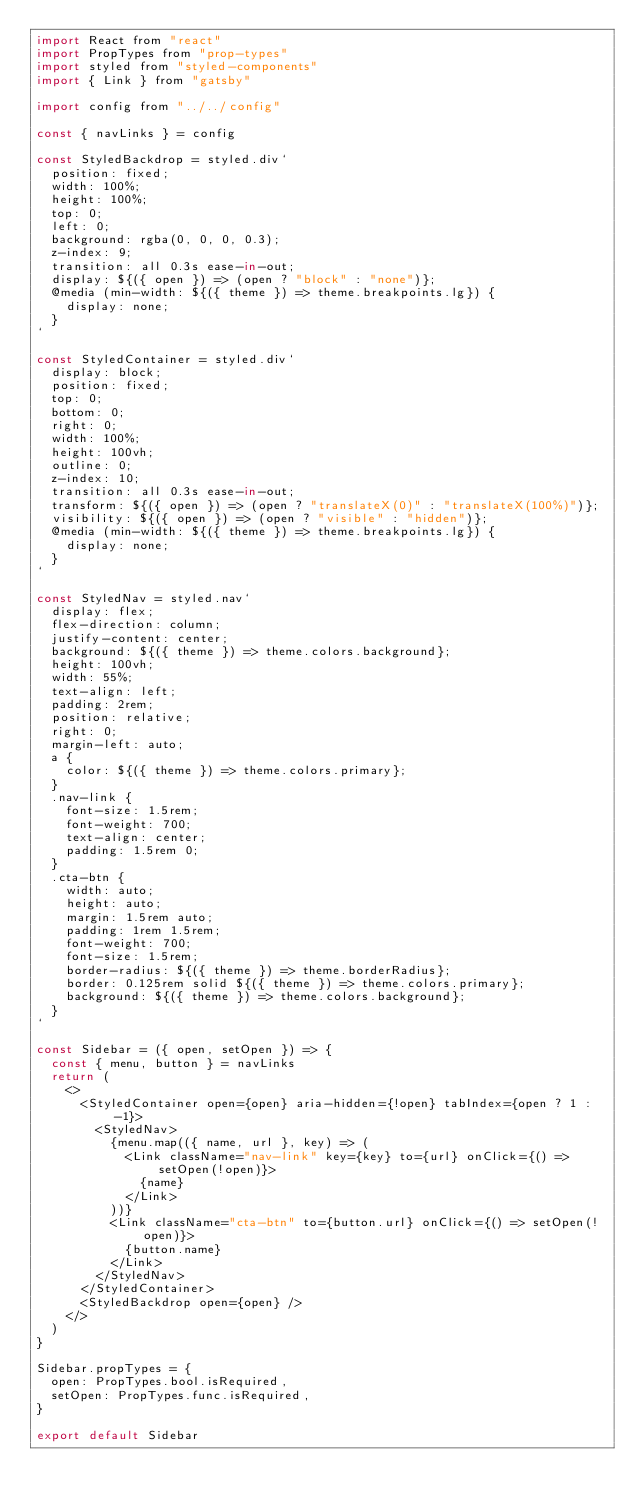<code> <loc_0><loc_0><loc_500><loc_500><_JavaScript_>import React from "react"
import PropTypes from "prop-types"
import styled from "styled-components"
import { Link } from "gatsby"

import config from "../../config"

const { navLinks } = config

const StyledBackdrop = styled.div`
  position: fixed;
  width: 100%;
  height: 100%;
  top: 0;
  left: 0;
  background: rgba(0, 0, 0, 0.3);
  z-index: 9;
  transition: all 0.3s ease-in-out;
  display: ${({ open }) => (open ? "block" : "none")};
  @media (min-width: ${({ theme }) => theme.breakpoints.lg}) {
    display: none;
  }
`

const StyledContainer = styled.div`
  display: block;
  position: fixed;
  top: 0;
  bottom: 0;
  right: 0;
  width: 100%;
  height: 100vh;
  outline: 0;
  z-index: 10;
  transition: all 0.3s ease-in-out;
  transform: ${({ open }) => (open ? "translateX(0)" : "translateX(100%)")};
  visibility: ${({ open }) => (open ? "visible" : "hidden")};
  @media (min-width: ${({ theme }) => theme.breakpoints.lg}) {
    display: none;
  }
`

const StyledNav = styled.nav`
  display: flex;
  flex-direction: column;
  justify-content: center;
  background: ${({ theme }) => theme.colors.background};
  height: 100vh;
  width: 55%;
  text-align: left;
  padding: 2rem;
  position: relative;
  right: 0;
  margin-left: auto;
  a {
    color: ${({ theme }) => theme.colors.primary};
  }
  .nav-link {
    font-size: 1.5rem;
    font-weight: 700;
    text-align: center;
    padding: 1.5rem 0;
  }
  .cta-btn {
    width: auto;
    height: auto;
    margin: 1.5rem auto;
    padding: 1rem 1.5rem;
    font-weight: 700;
    font-size: 1.5rem;
    border-radius: ${({ theme }) => theme.borderRadius};
    border: 0.125rem solid ${({ theme }) => theme.colors.primary};
    background: ${({ theme }) => theme.colors.background};
  }
`

const Sidebar = ({ open, setOpen }) => {
  const { menu, button } = navLinks
  return (
    <>
      <StyledContainer open={open} aria-hidden={!open} tabIndex={open ? 1 : -1}>
        <StyledNav>
          {menu.map(({ name, url }, key) => (
            <Link className="nav-link" key={key} to={url} onClick={() => setOpen(!open)}>
              {name}
            </Link>
          ))}
          <Link className="cta-btn" to={button.url} onClick={() => setOpen(!open)}>
            {button.name}
          </Link>
        </StyledNav>
      </StyledContainer>
      <StyledBackdrop open={open} />
    </>
  )
}

Sidebar.propTypes = {
  open: PropTypes.bool.isRequired,
  setOpen: PropTypes.func.isRequired,
}

export default Sidebar
</code> 